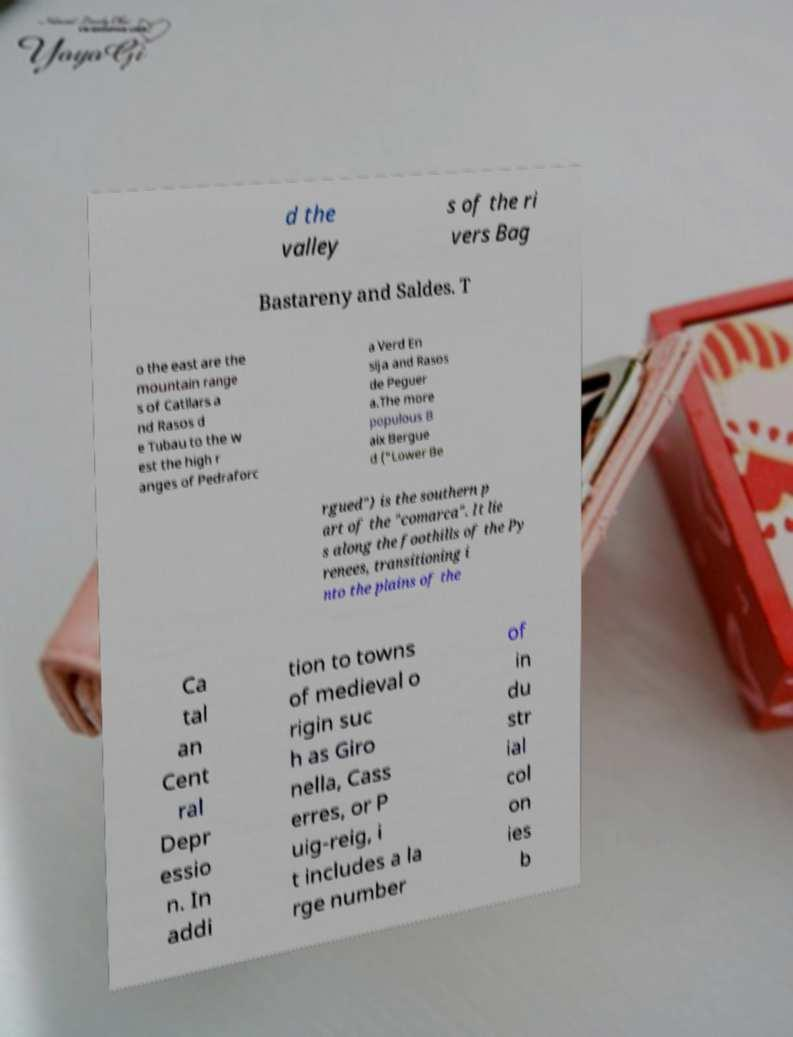Can you accurately transcribe the text from the provided image for me? d the valley s of the ri vers Bag Bastareny and Saldes. T o the east are the mountain range s of Catllars a nd Rasos d e Tubau to the w est the high r anges of Pedraforc a Verd En sija and Rasos de Peguer a.The more populous B aix Bergue d ("Lower Be rgued") is the southern p art of the "comarca". It lie s along the foothills of the Py renees, transitioning i nto the plains of the Ca tal an Cent ral Depr essio n. In addi tion to towns of medieval o rigin suc h as Giro nella, Cass erres, or P uig-reig, i t includes a la rge number of in du str ial col on ies b 